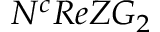<formula> <loc_0><loc_0><loc_500><loc_500>N ^ { c } R e Z G _ { 2 }</formula> 